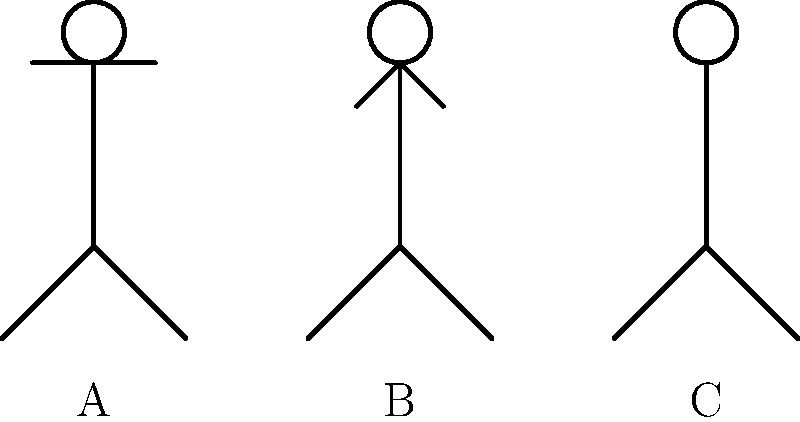Which of the stick figures (A, B, or C) represents the correct hand signal for indicating a direct free kick in soccer? To answer this question, let's analyze the hand signals shown by each stick figure:

1. Figure A: Arms are straight down by the sides. This is not a specific signal in soccer.

2. Figure B: One arm is raised at approximately a 45-degree angle. This signal is often used to indicate advantage play, not a direct free kick.

3. Figure C: One arm is raised straight up, pointing vertically. This is the correct signal for indicating a direct free kick in soccer.

In soccer, referees use clear and distinct hand signals to communicate their decisions to players, coaches, and spectators. For a direct free kick, the referee points with a straight arm in the direction of the kick (i.e., towards the goal of the team that committed the foul). This is represented by Figure C in the illustration.

It's important for aspiring soccer officials to memorize and practice these signals to ensure clear communication on the field. The straight arm raised vertically is unambiguous and can be easily seen from various positions on the field.
Answer: C 